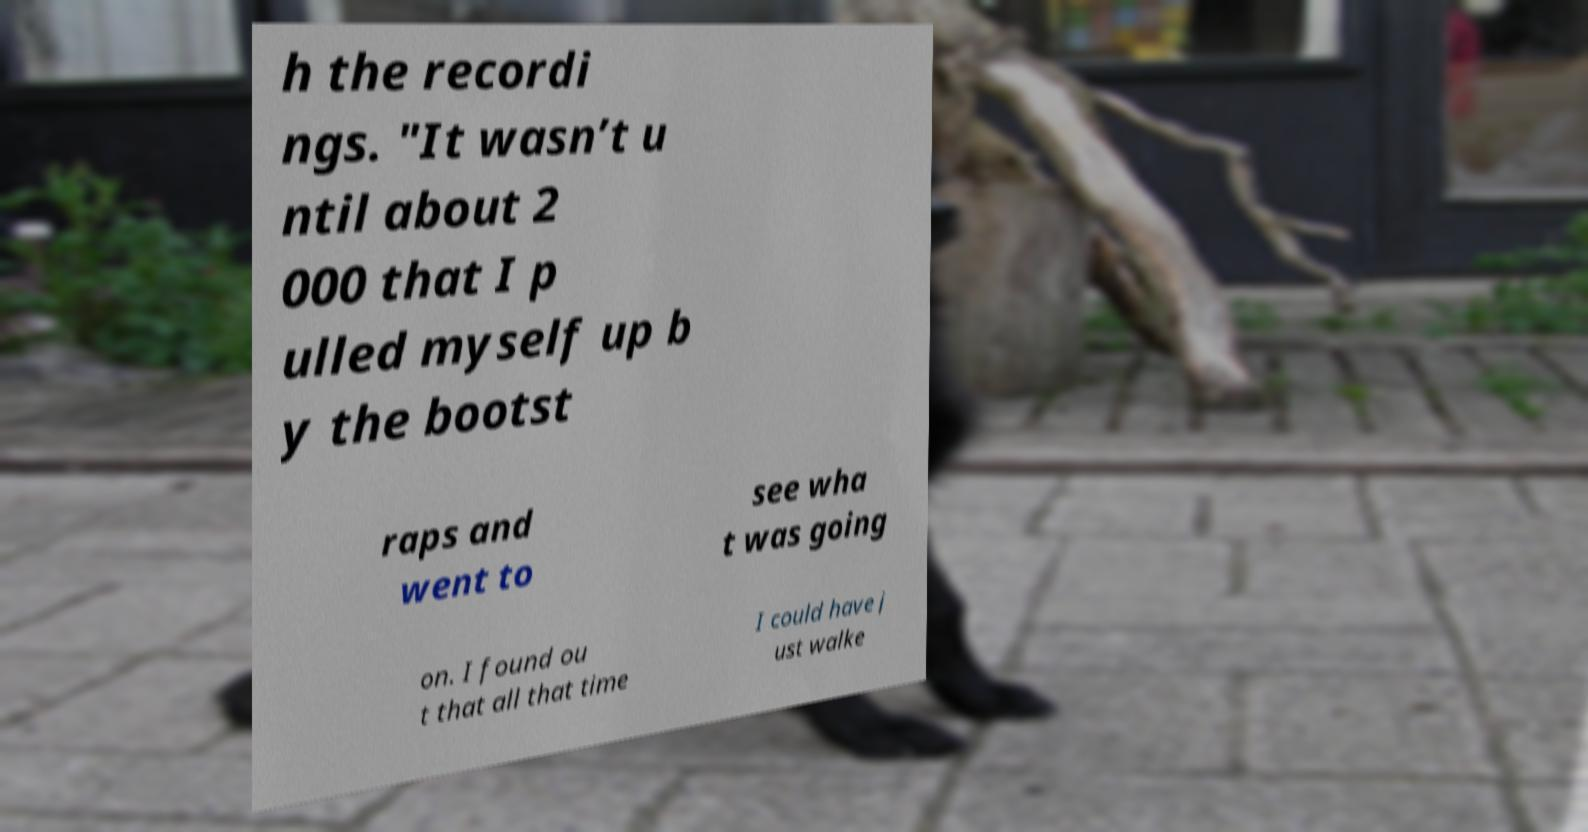I need the written content from this picture converted into text. Can you do that? h the recordi ngs. "It wasn’t u ntil about 2 000 that I p ulled myself up b y the bootst raps and went to see wha t was going on. I found ou t that all that time I could have j ust walke 